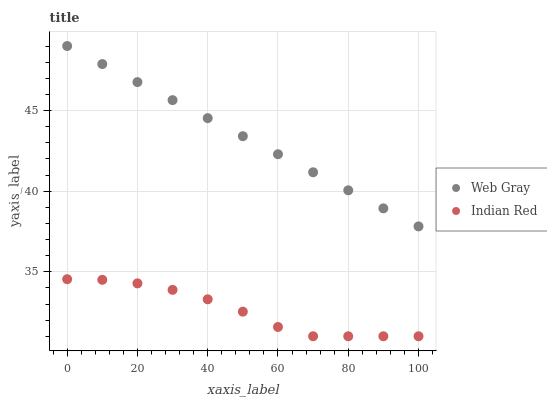Does Indian Red have the minimum area under the curve?
Answer yes or no. Yes. Does Web Gray have the maximum area under the curve?
Answer yes or no. Yes. Does Indian Red have the maximum area under the curve?
Answer yes or no. No. Is Web Gray the smoothest?
Answer yes or no. Yes. Is Indian Red the roughest?
Answer yes or no. Yes. Is Indian Red the smoothest?
Answer yes or no. No. Does Indian Red have the lowest value?
Answer yes or no. Yes. Does Web Gray have the highest value?
Answer yes or no. Yes. Does Indian Red have the highest value?
Answer yes or no. No. Is Indian Red less than Web Gray?
Answer yes or no. Yes. Is Web Gray greater than Indian Red?
Answer yes or no. Yes. Does Indian Red intersect Web Gray?
Answer yes or no. No. 